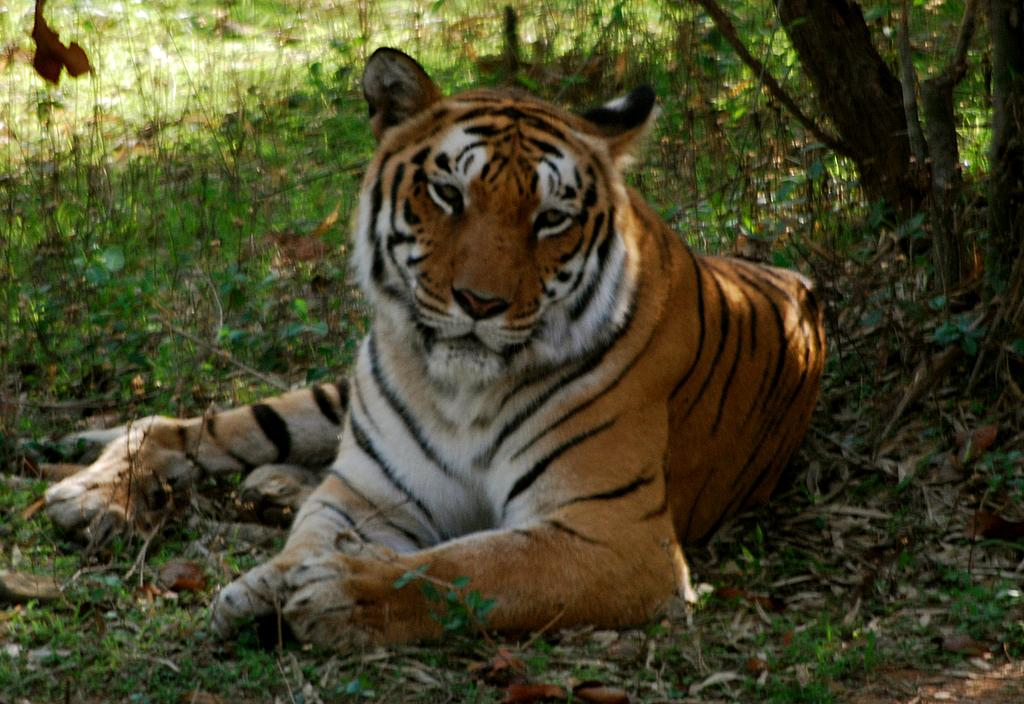What animal is in the center of the image? There is a tiger in the center of the image. What type of vegetation can be seen in the image? There is grass visible in the image. What else can be found on the ground in the image? Dried leaves are present in the image. What is located on the right side of the image? There are trees on the right side of the image. Where is the oven located in the image? There is no oven present in the image. What type of stick can be seen in the tiger's paw? There is no stick present in the image; the tiger's paws are empty. 